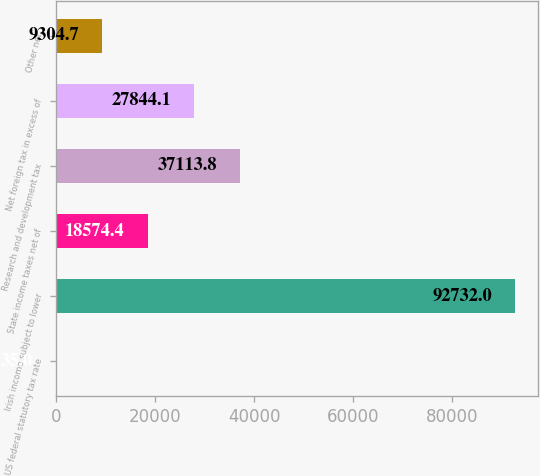Convert chart to OTSL. <chart><loc_0><loc_0><loc_500><loc_500><bar_chart><fcel>US federal statutory tax rate<fcel>Irish income subject to lower<fcel>State income taxes net of<fcel>Research and development tax<fcel>Net foreign tax in excess of<fcel>Other net<nl><fcel>35<fcel>92732<fcel>18574.4<fcel>37113.8<fcel>27844.1<fcel>9304.7<nl></chart> 